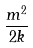<formula> <loc_0><loc_0><loc_500><loc_500>\frac { m ^ { 2 } } { 2 k }</formula> 